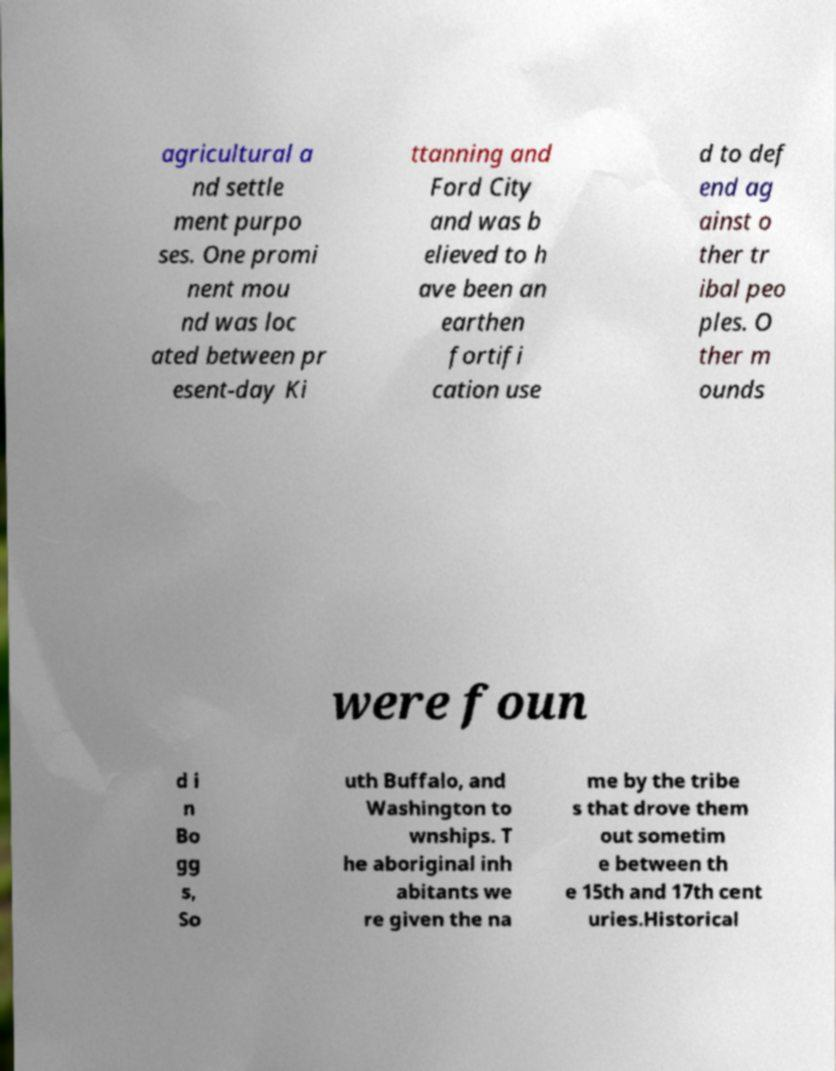Can you accurately transcribe the text from the provided image for me? agricultural a nd settle ment purpo ses. One promi nent mou nd was loc ated between pr esent-day Ki ttanning and Ford City and was b elieved to h ave been an earthen fortifi cation use d to def end ag ainst o ther tr ibal peo ples. O ther m ounds were foun d i n Bo gg s, So uth Buffalo, and Washington to wnships. T he aboriginal inh abitants we re given the na me by the tribe s that drove them out sometim e between th e 15th and 17th cent uries.Historical 